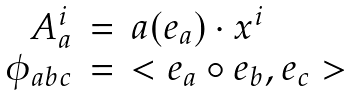Convert formula to latex. <formula><loc_0><loc_0><loc_500><loc_500>\begin{array} { r c l } A ^ { i } _ { a } & = & a ( e _ { a } ) \cdot x ^ { i } \\ \phi _ { a b c } & = & < e _ { a } \circ e _ { b } , e _ { c } > \end{array}</formula> 